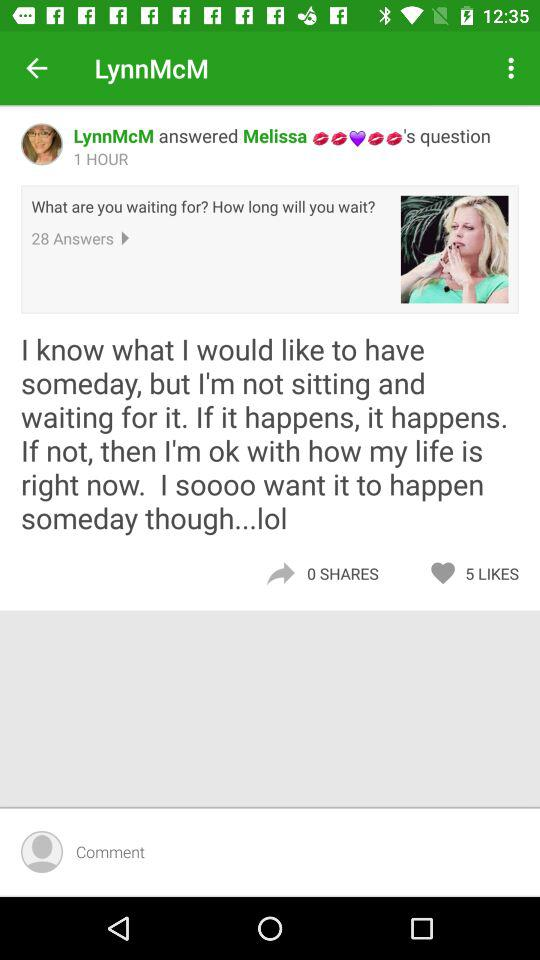How many likes does the post have?
Answer the question using a single word or phrase. 5 